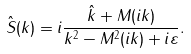<formula> <loc_0><loc_0><loc_500><loc_500>\hat { S } ( k ) = i \frac { \hat { k } + M ( i k ) } { k ^ { 2 } - M ^ { 2 } ( i k ) + i \varepsilon } .</formula> 